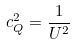Convert formula to latex. <formula><loc_0><loc_0><loc_500><loc_500>c _ { Q } ^ { 2 } = \frac { 1 } { U ^ { 2 } }</formula> 